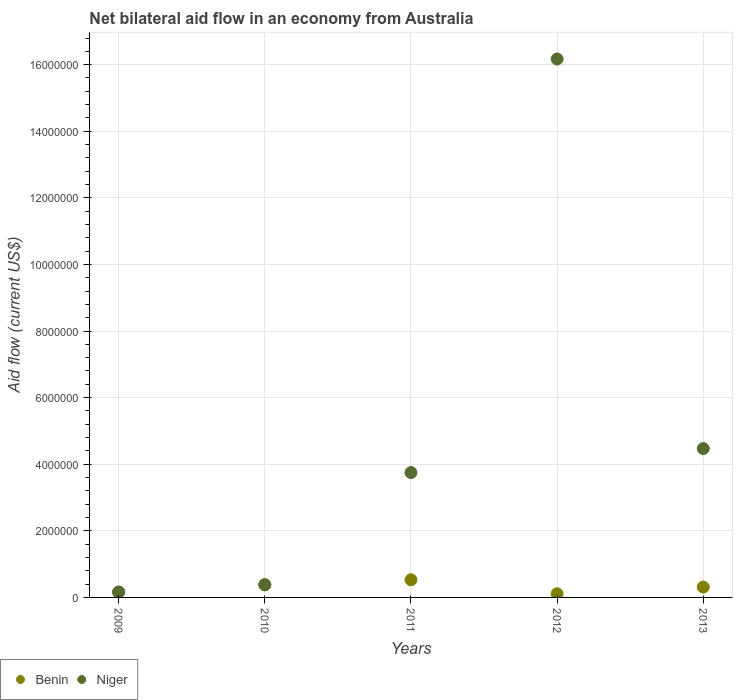How many different coloured dotlines are there?
Your response must be concise. 2. Is the number of dotlines equal to the number of legend labels?
Offer a very short reply. Yes. What is the net bilateral aid flow in Benin in 2009?
Offer a very short reply. 1.60e+05. Across all years, what is the maximum net bilateral aid flow in Benin?
Provide a succinct answer. 5.30e+05. In which year was the net bilateral aid flow in Benin maximum?
Make the answer very short. 2011. What is the total net bilateral aid flow in Benin in the graph?
Give a very brief answer. 1.49e+06. What is the difference between the net bilateral aid flow in Niger in 2013 and the net bilateral aid flow in Benin in 2009?
Your answer should be very brief. 4.31e+06. What is the average net bilateral aid flow in Niger per year?
Offer a terse response. 4.99e+06. In the year 2011, what is the difference between the net bilateral aid flow in Niger and net bilateral aid flow in Benin?
Ensure brevity in your answer.  3.22e+06. What is the ratio of the net bilateral aid flow in Benin in 2012 to that in 2013?
Your response must be concise. 0.35. Is the net bilateral aid flow in Benin in 2011 less than that in 2012?
Give a very brief answer. No. What is the difference between the highest and the lowest net bilateral aid flow in Benin?
Ensure brevity in your answer.  4.20e+05. Is the sum of the net bilateral aid flow in Niger in 2009 and 2011 greater than the maximum net bilateral aid flow in Benin across all years?
Your answer should be compact. Yes. Does the net bilateral aid flow in Niger monotonically increase over the years?
Ensure brevity in your answer.  No. Is the net bilateral aid flow in Niger strictly less than the net bilateral aid flow in Benin over the years?
Ensure brevity in your answer.  No. How many dotlines are there?
Your answer should be very brief. 2. How many years are there in the graph?
Provide a succinct answer. 5. Are the values on the major ticks of Y-axis written in scientific E-notation?
Offer a very short reply. No. Where does the legend appear in the graph?
Provide a succinct answer. Bottom left. How many legend labels are there?
Give a very brief answer. 2. What is the title of the graph?
Your response must be concise. Net bilateral aid flow in an economy from Australia. Does "Germany" appear as one of the legend labels in the graph?
Your answer should be very brief. No. What is the label or title of the X-axis?
Ensure brevity in your answer.  Years. What is the Aid flow (current US$) in Benin in 2009?
Provide a succinct answer. 1.60e+05. What is the Aid flow (current US$) of Niger in 2010?
Ensure brevity in your answer.  3.80e+05. What is the Aid flow (current US$) in Benin in 2011?
Provide a short and direct response. 5.30e+05. What is the Aid flow (current US$) in Niger in 2011?
Give a very brief answer. 3.75e+06. What is the Aid flow (current US$) of Benin in 2012?
Offer a terse response. 1.10e+05. What is the Aid flow (current US$) of Niger in 2012?
Your response must be concise. 1.62e+07. What is the Aid flow (current US$) of Benin in 2013?
Give a very brief answer. 3.10e+05. What is the Aid flow (current US$) in Niger in 2013?
Your answer should be compact. 4.47e+06. Across all years, what is the maximum Aid flow (current US$) of Benin?
Give a very brief answer. 5.30e+05. Across all years, what is the maximum Aid flow (current US$) in Niger?
Make the answer very short. 1.62e+07. What is the total Aid flow (current US$) of Benin in the graph?
Offer a terse response. 1.49e+06. What is the total Aid flow (current US$) of Niger in the graph?
Offer a terse response. 2.49e+07. What is the difference between the Aid flow (current US$) in Benin in 2009 and that in 2011?
Make the answer very short. -3.70e+05. What is the difference between the Aid flow (current US$) of Niger in 2009 and that in 2011?
Provide a short and direct response. -3.59e+06. What is the difference between the Aid flow (current US$) of Benin in 2009 and that in 2012?
Make the answer very short. 5.00e+04. What is the difference between the Aid flow (current US$) of Niger in 2009 and that in 2012?
Provide a succinct answer. -1.60e+07. What is the difference between the Aid flow (current US$) of Benin in 2009 and that in 2013?
Your answer should be compact. -1.50e+05. What is the difference between the Aid flow (current US$) of Niger in 2009 and that in 2013?
Your response must be concise. -4.31e+06. What is the difference between the Aid flow (current US$) of Niger in 2010 and that in 2011?
Give a very brief answer. -3.37e+06. What is the difference between the Aid flow (current US$) of Niger in 2010 and that in 2012?
Offer a very short reply. -1.58e+07. What is the difference between the Aid flow (current US$) of Benin in 2010 and that in 2013?
Ensure brevity in your answer.  7.00e+04. What is the difference between the Aid flow (current US$) of Niger in 2010 and that in 2013?
Provide a short and direct response. -4.09e+06. What is the difference between the Aid flow (current US$) of Benin in 2011 and that in 2012?
Ensure brevity in your answer.  4.20e+05. What is the difference between the Aid flow (current US$) of Niger in 2011 and that in 2012?
Keep it short and to the point. -1.24e+07. What is the difference between the Aid flow (current US$) of Niger in 2011 and that in 2013?
Make the answer very short. -7.20e+05. What is the difference between the Aid flow (current US$) of Benin in 2012 and that in 2013?
Provide a short and direct response. -2.00e+05. What is the difference between the Aid flow (current US$) of Niger in 2012 and that in 2013?
Keep it short and to the point. 1.17e+07. What is the difference between the Aid flow (current US$) in Benin in 2009 and the Aid flow (current US$) in Niger in 2011?
Offer a very short reply. -3.59e+06. What is the difference between the Aid flow (current US$) of Benin in 2009 and the Aid flow (current US$) of Niger in 2012?
Your response must be concise. -1.60e+07. What is the difference between the Aid flow (current US$) of Benin in 2009 and the Aid flow (current US$) of Niger in 2013?
Offer a very short reply. -4.31e+06. What is the difference between the Aid flow (current US$) of Benin in 2010 and the Aid flow (current US$) of Niger in 2011?
Offer a very short reply. -3.37e+06. What is the difference between the Aid flow (current US$) in Benin in 2010 and the Aid flow (current US$) in Niger in 2012?
Offer a very short reply. -1.58e+07. What is the difference between the Aid flow (current US$) in Benin in 2010 and the Aid flow (current US$) in Niger in 2013?
Keep it short and to the point. -4.09e+06. What is the difference between the Aid flow (current US$) in Benin in 2011 and the Aid flow (current US$) in Niger in 2012?
Provide a succinct answer. -1.56e+07. What is the difference between the Aid flow (current US$) of Benin in 2011 and the Aid flow (current US$) of Niger in 2013?
Make the answer very short. -3.94e+06. What is the difference between the Aid flow (current US$) in Benin in 2012 and the Aid flow (current US$) in Niger in 2013?
Your response must be concise. -4.36e+06. What is the average Aid flow (current US$) in Benin per year?
Offer a very short reply. 2.98e+05. What is the average Aid flow (current US$) in Niger per year?
Ensure brevity in your answer.  4.99e+06. In the year 2009, what is the difference between the Aid flow (current US$) in Benin and Aid flow (current US$) in Niger?
Your answer should be compact. 0. In the year 2010, what is the difference between the Aid flow (current US$) of Benin and Aid flow (current US$) of Niger?
Your answer should be compact. 0. In the year 2011, what is the difference between the Aid flow (current US$) of Benin and Aid flow (current US$) of Niger?
Your response must be concise. -3.22e+06. In the year 2012, what is the difference between the Aid flow (current US$) of Benin and Aid flow (current US$) of Niger?
Keep it short and to the point. -1.61e+07. In the year 2013, what is the difference between the Aid flow (current US$) in Benin and Aid flow (current US$) in Niger?
Make the answer very short. -4.16e+06. What is the ratio of the Aid flow (current US$) in Benin in 2009 to that in 2010?
Offer a very short reply. 0.42. What is the ratio of the Aid flow (current US$) of Niger in 2009 to that in 2010?
Your answer should be very brief. 0.42. What is the ratio of the Aid flow (current US$) of Benin in 2009 to that in 2011?
Your answer should be very brief. 0.3. What is the ratio of the Aid flow (current US$) of Niger in 2009 to that in 2011?
Your answer should be very brief. 0.04. What is the ratio of the Aid flow (current US$) in Benin in 2009 to that in 2012?
Make the answer very short. 1.45. What is the ratio of the Aid flow (current US$) in Niger in 2009 to that in 2012?
Provide a short and direct response. 0.01. What is the ratio of the Aid flow (current US$) in Benin in 2009 to that in 2013?
Make the answer very short. 0.52. What is the ratio of the Aid flow (current US$) of Niger in 2009 to that in 2013?
Make the answer very short. 0.04. What is the ratio of the Aid flow (current US$) in Benin in 2010 to that in 2011?
Offer a very short reply. 0.72. What is the ratio of the Aid flow (current US$) of Niger in 2010 to that in 2011?
Offer a very short reply. 0.1. What is the ratio of the Aid flow (current US$) of Benin in 2010 to that in 2012?
Provide a succinct answer. 3.45. What is the ratio of the Aid flow (current US$) of Niger in 2010 to that in 2012?
Keep it short and to the point. 0.02. What is the ratio of the Aid flow (current US$) of Benin in 2010 to that in 2013?
Offer a very short reply. 1.23. What is the ratio of the Aid flow (current US$) in Niger in 2010 to that in 2013?
Give a very brief answer. 0.09. What is the ratio of the Aid flow (current US$) of Benin in 2011 to that in 2012?
Make the answer very short. 4.82. What is the ratio of the Aid flow (current US$) in Niger in 2011 to that in 2012?
Your response must be concise. 0.23. What is the ratio of the Aid flow (current US$) in Benin in 2011 to that in 2013?
Your answer should be compact. 1.71. What is the ratio of the Aid flow (current US$) of Niger in 2011 to that in 2013?
Your answer should be compact. 0.84. What is the ratio of the Aid flow (current US$) in Benin in 2012 to that in 2013?
Offer a terse response. 0.35. What is the ratio of the Aid flow (current US$) of Niger in 2012 to that in 2013?
Provide a succinct answer. 3.62. What is the difference between the highest and the second highest Aid flow (current US$) of Benin?
Offer a terse response. 1.50e+05. What is the difference between the highest and the second highest Aid flow (current US$) in Niger?
Your answer should be compact. 1.17e+07. What is the difference between the highest and the lowest Aid flow (current US$) in Niger?
Your answer should be compact. 1.60e+07. 